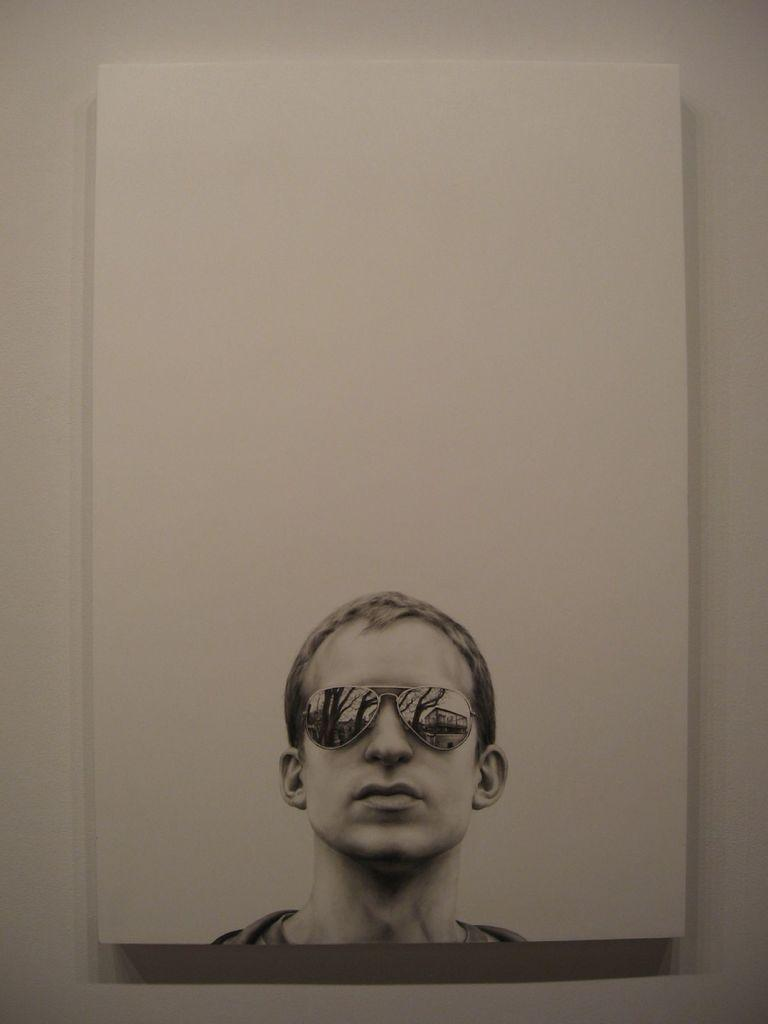What type of structure can be seen in the image? There is a wall in the image. What is depicted on or near the wall? There is some form of art in the image. What type of muscle is being exercised by the actor in the image? There is no actor or muscle present in the image; it only features a wall and some form of art. 